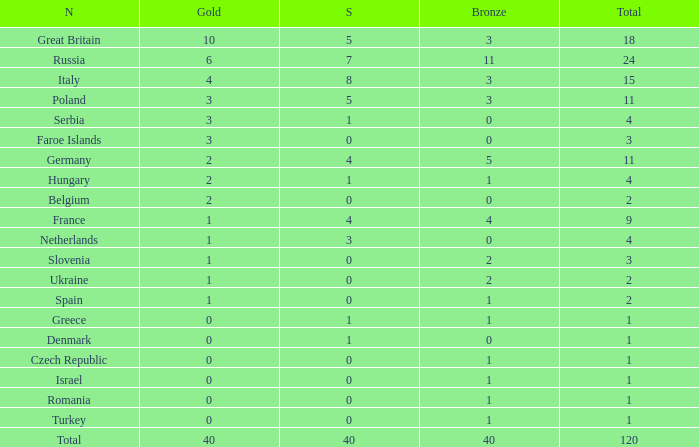What Nation has a Gold entry that is greater than 0, a Total that is greater than 2, a Silver entry that is larger than 1, and 0 Bronze? Netherlands. 